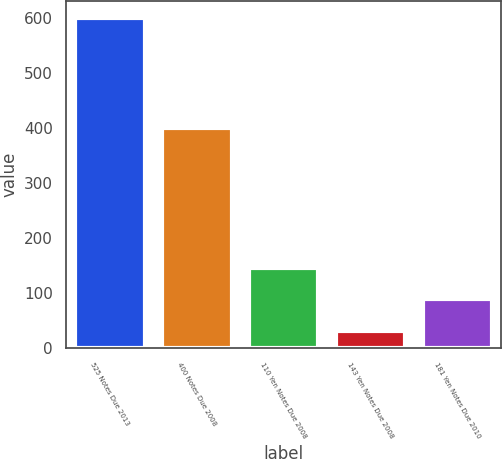<chart> <loc_0><loc_0><loc_500><loc_500><bar_chart><fcel>525 Notes Due 2013<fcel>400 Notes Due 2008<fcel>110 Yen Notes Due 2008<fcel>143 Yen Notes Due 2008<fcel>181 Yen Notes Due 2010<nl><fcel>600<fcel>400<fcel>145.6<fcel>32<fcel>88.8<nl></chart> 